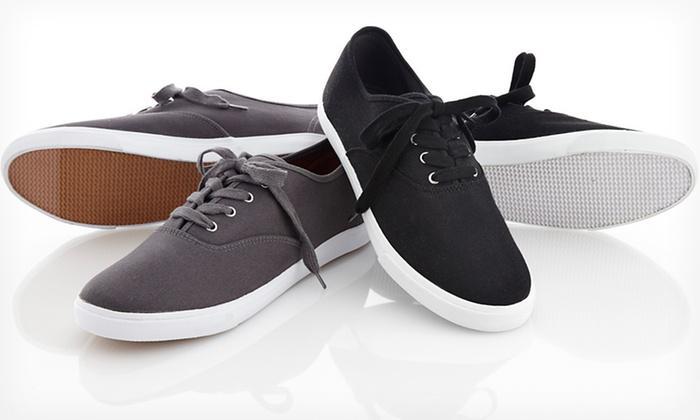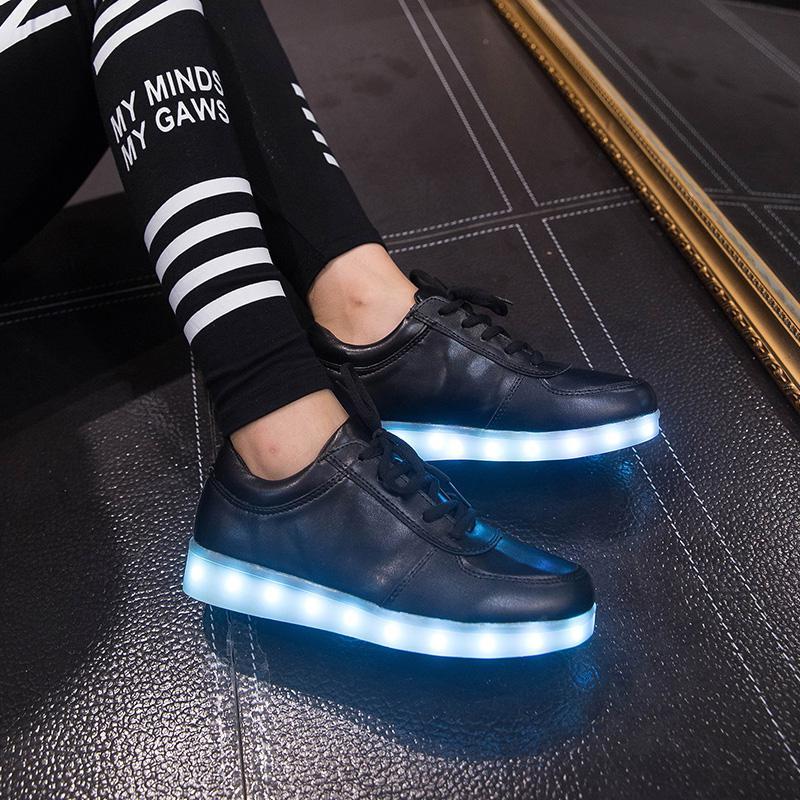The first image is the image on the left, the second image is the image on the right. Assess this claim about the two images: "At least one person is wearing the shoes.". Correct or not? Answer yes or no. Yes. The first image is the image on the left, the second image is the image on the right. Examine the images to the left and right. Is the description "There are exactly eight shoes visible." accurate? Answer yes or no. No. 